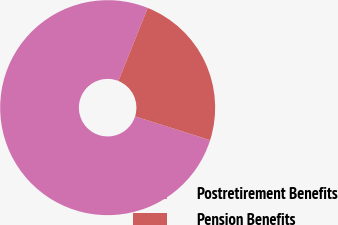Convert chart. <chart><loc_0><loc_0><loc_500><loc_500><pie_chart><fcel>Postretirement Benefits<fcel>Pension Benefits<nl><fcel>76.19%<fcel>23.81%<nl></chart> 